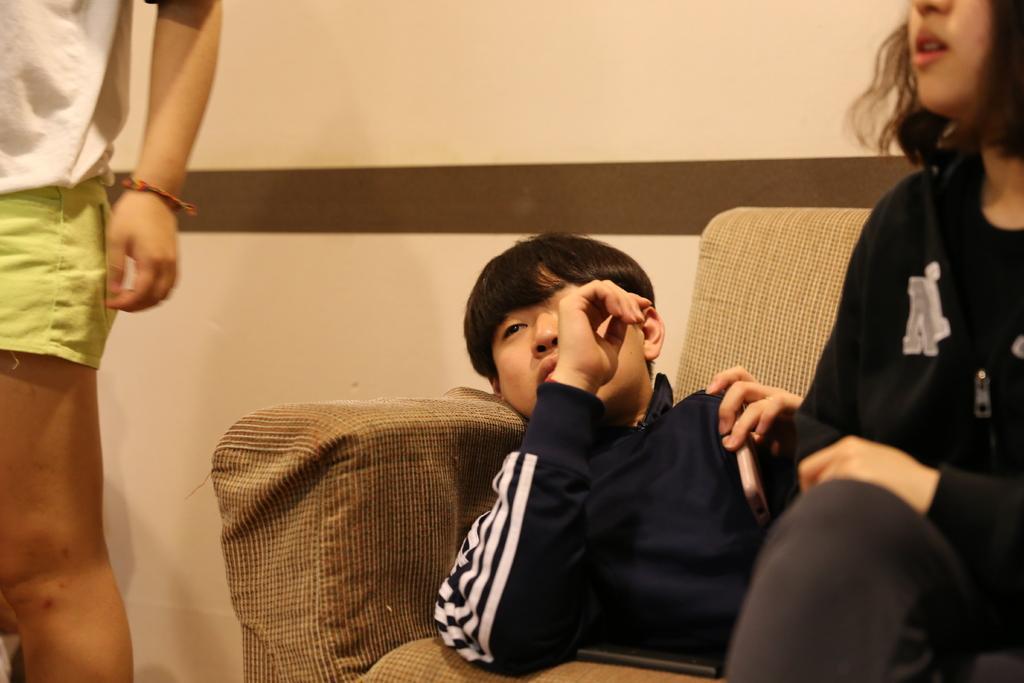In one or two sentences, can you explain what this image depicts? In this image I can see a man is lying on the sofa. On the right side a woman is sitting on the sofa, she wore black color dress. In the middle it looks like a wall. 